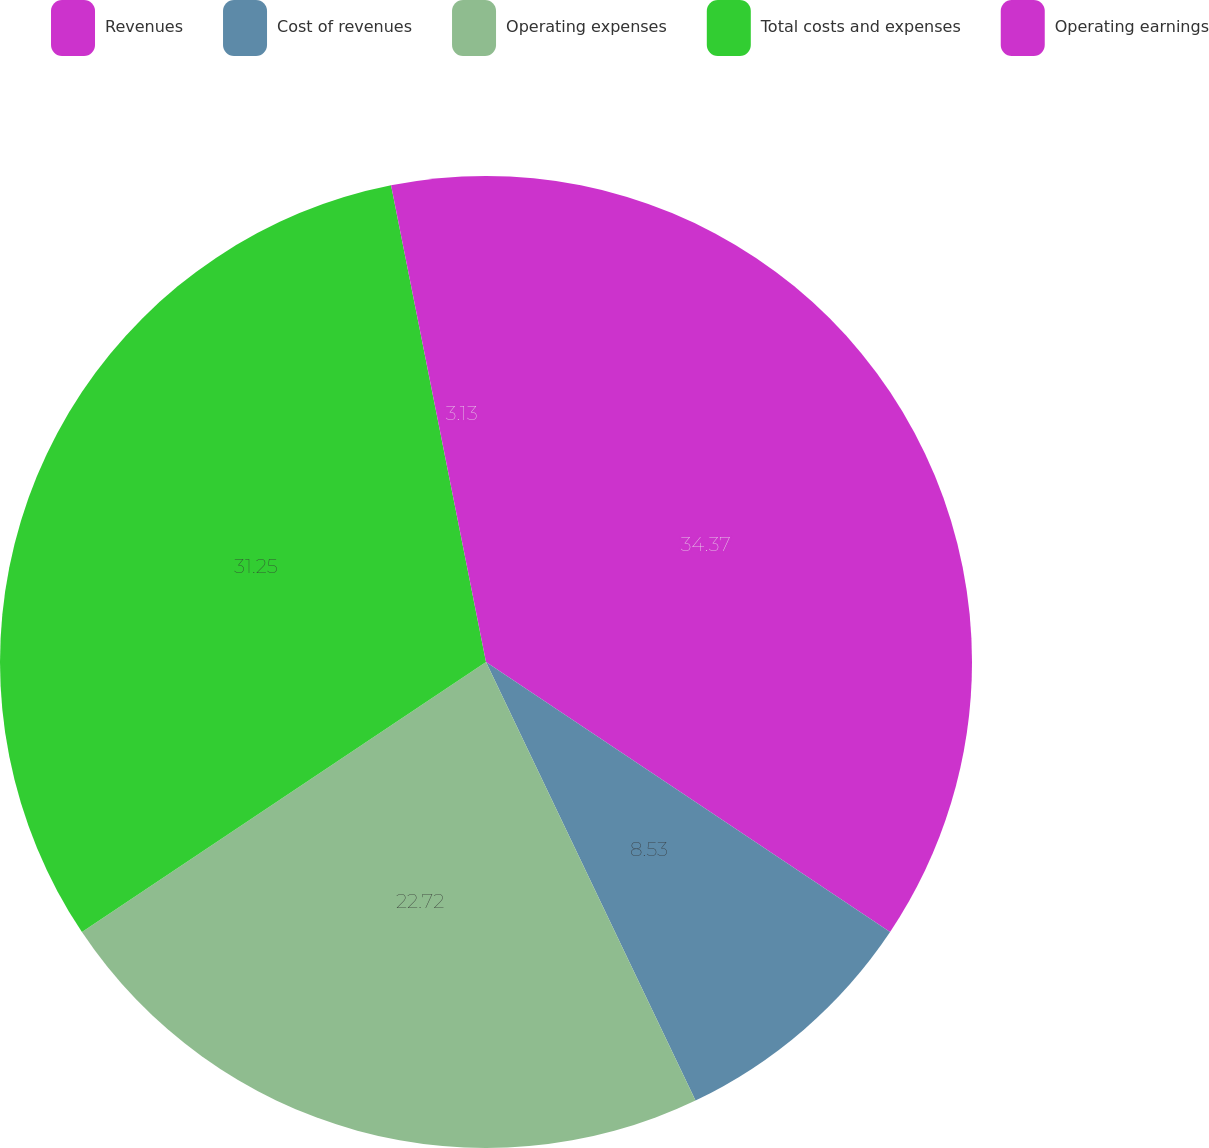Convert chart to OTSL. <chart><loc_0><loc_0><loc_500><loc_500><pie_chart><fcel>Revenues<fcel>Cost of revenues<fcel>Operating expenses<fcel>Total costs and expenses<fcel>Operating earnings<nl><fcel>34.38%<fcel>8.53%<fcel>22.72%<fcel>31.25%<fcel>3.13%<nl></chart> 